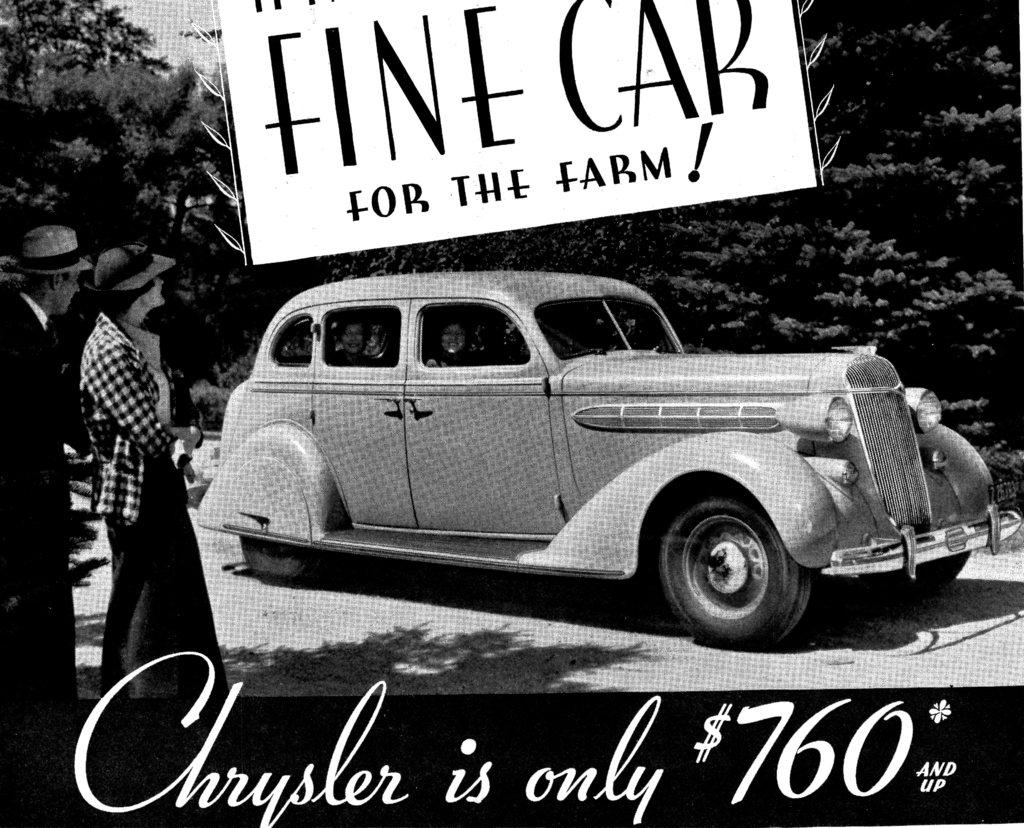How many people are in the image? There are two persons standing in the image. What are the persons looking at? The persons are looking at a board. What is on the ground in the image? There is a vehicle on the ground in the image. What type of natural scenery can be seen in the image? There are trees visible in the image. What is written on the poster in the image? There is text written on a poster in the image. Who is the owner of the window in the image? There is no window present in the image, so it is not possible to determine the owner. What type of pump can be seen in the image? There is no pump present in the image. 